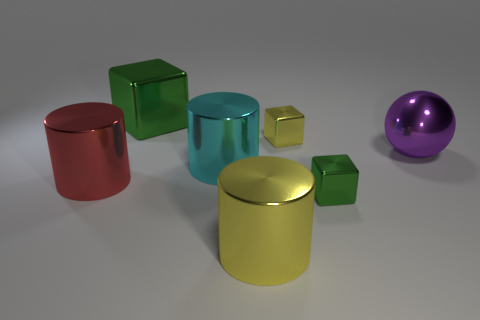Can you describe the lighting of the scene? The lighting of the scene appears to be soft and diffused, providing a gentle glow on the objects and creating subtle shadows that don't overwhelm the view. This type of lighting minimizes harsh contrasts and helps maintain the focus on the colors and shapes of the objects. 